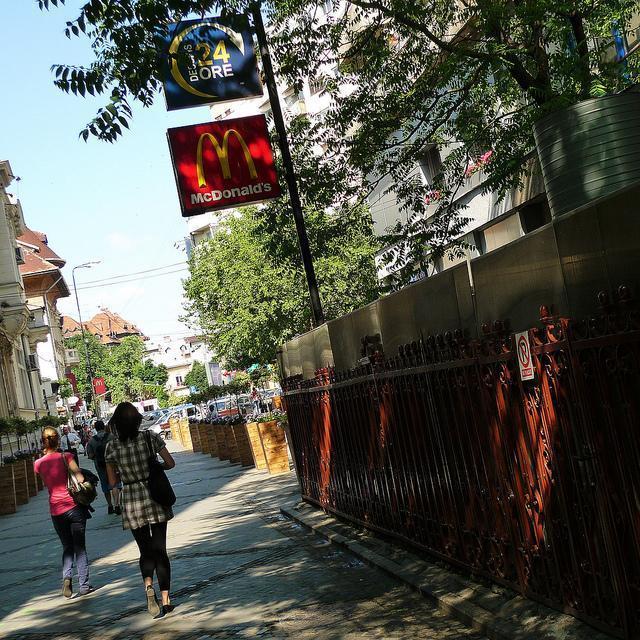How many people are there?
Give a very brief answer. 2. 